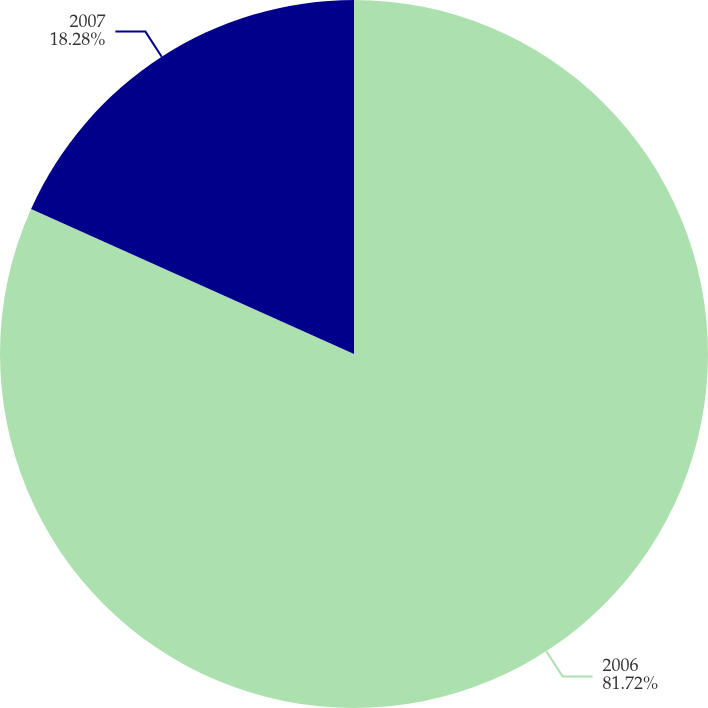Convert chart. <chart><loc_0><loc_0><loc_500><loc_500><pie_chart><fcel>2006<fcel>2007<nl><fcel>81.72%<fcel>18.28%<nl></chart> 